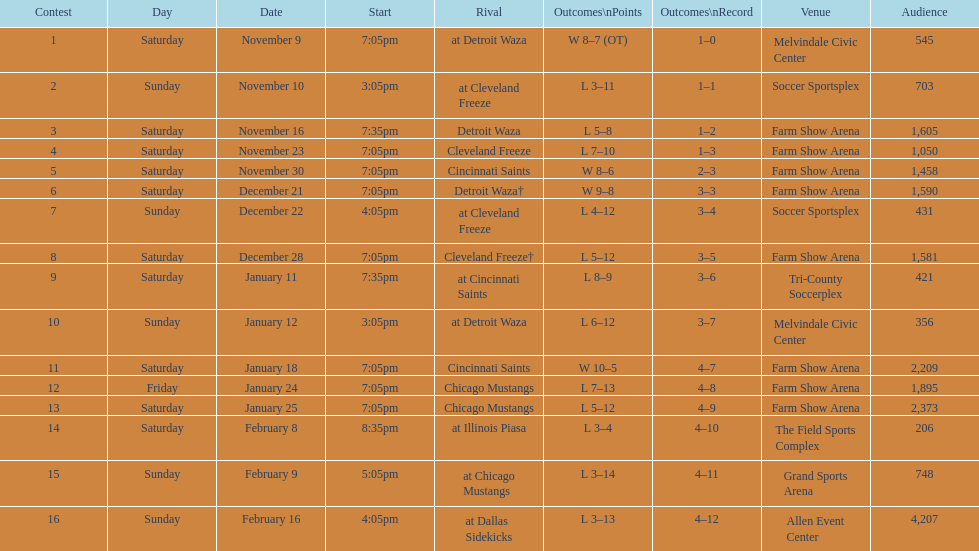Which opponent is listed after cleveland freeze in the table? Detroit Waza. 